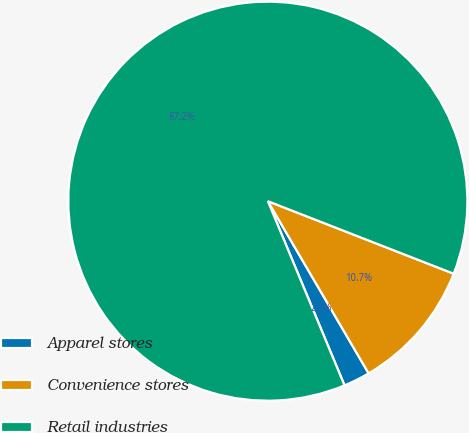Convert chart. <chart><loc_0><loc_0><loc_500><loc_500><pie_chart><fcel>Apparel stores<fcel>Convenience stores<fcel>Retail industries<nl><fcel>2.15%<fcel>10.65%<fcel>87.19%<nl></chart> 